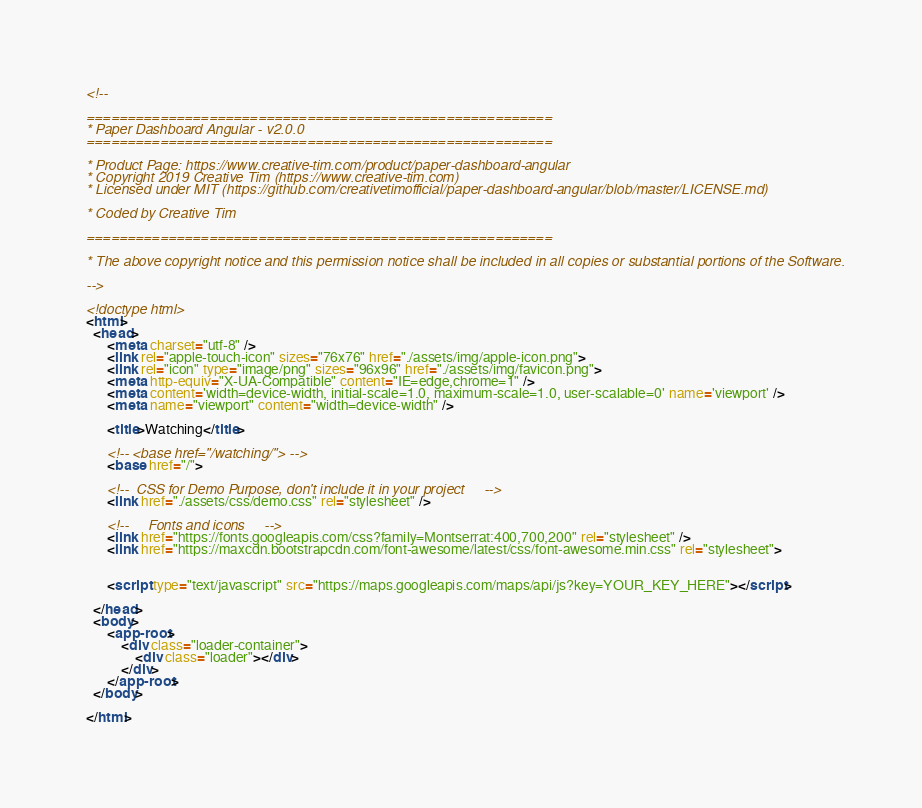<code> <loc_0><loc_0><loc_500><loc_500><_HTML_><!--

=========================================================
* Paper Dashboard Angular - v2.0.0
=========================================================

* Product Page: https://www.creative-tim.com/product/paper-dashboard-angular
* Copyright 2019 Creative Tim (https://www.creative-tim.com)
* Licensed under MIT (https://github.com/creativetimofficial/paper-dashboard-angular/blob/master/LICENSE.md)

* Coded by Creative Tim

=========================================================

* The above copyright notice and this permission notice shall be included in all copies or substantial portions of the Software.

-->

<!doctype html>
<html>
  <head>
      <meta charset="utf-8" />
      <link rel="apple-touch-icon" sizes="76x76" href="./assets/img/apple-icon.png">
      <link rel="icon" type="image/png" sizes="96x96" href="./assets/img/favicon.png">
      <meta http-equiv="X-UA-Compatible" content="IE=edge,chrome=1" />
      <meta content='width=device-width, initial-scale=1.0, maximum-scale=1.0, user-scalable=0' name='viewport' />
      <meta name="viewport" content="width=device-width" />

      <title>Watching</title>

      <!-- <base href="/watching/"> -->
      <base href="/">

      <!--  CSS for Demo Purpose, don't include it in your project     -->
      <link href="./assets/css/demo.css" rel="stylesheet" />

      <!--     Fonts and icons     -->
      <link href="https://fonts.googleapis.com/css?family=Montserrat:400,700,200" rel="stylesheet" />
      <link href="https://maxcdn.bootstrapcdn.com/font-awesome/latest/css/font-awesome.min.css" rel="stylesheet">


      <script type="text/javascript" src="https://maps.googleapis.com/maps/api/js?key=YOUR_KEY_HERE"></script>

  </head>
  <body>
      <app-root>
          <div class="loader-container">
              <div class="loader"></div>
          </div>
      </app-root>
  </body>

</html>
</code> 